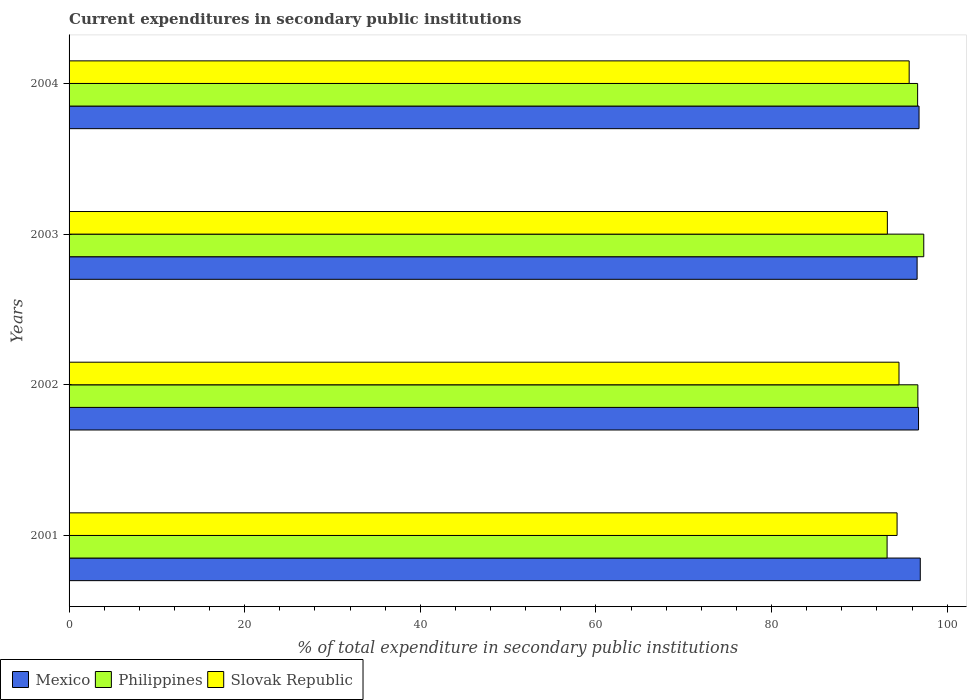How many groups of bars are there?
Give a very brief answer. 4. Are the number of bars per tick equal to the number of legend labels?
Your answer should be compact. Yes. Are the number of bars on each tick of the Y-axis equal?
Your answer should be very brief. Yes. How many bars are there on the 2nd tick from the bottom?
Your answer should be compact. 3. What is the current expenditures in secondary public institutions in Mexico in 2004?
Make the answer very short. 96.8. Across all years, what is the maximum current expenditures in secondary public institutions in Slovak Republic?
Offer a very short reply. 95.68. Across all years, what is the minimum current expenditures in secondary public institutions in Mexico?
Your response must be concise. 96.58. In which year was the current expenditures in secondary public institutions in Slovak Republic maximum?
Provide a succinct answer. 2004. What is the total current expenditures in secondary public institutions in Slovak Republic in the graph?
Provide a succinct answer. 377.7. What is the difference between the current expenditures in secondary public institutions in Slovak Republic in 2002 and that in 2003?
Ensure brevity in your answer.  1.33. What is the difference between the current expenditures in secondary public institutions in Philippines in 2001 and the current expenditures in secondary public institutions in Slovak Republic in 2003?
Make the answer very short. -0.03. What is the average current expenditures in secondary public institutions in Philippines per year?
Give a very brief answer. 95.95. In the year 2001, what is the difference between the current expenditures in secondary public institutions in Philippines and current expenditures in secondary public institutions in Mexico?
Provide a short and direct response. -3.78. In how many years, is the current expenditures in secondary public institutions in Mexico greater than 96 %?
Your answer should be compact. 4. What is the ratio of the current expenditures in secondary public institutions in Mexico in 2001 to that in 2004?
Your answer should be very brief. 1. Is the current expenditures in secondary public institutions in Slovak Republic in 2002 less than that in 2004?
Make the answer very short. Yes. What is the difference between the highest and the second highest current expenditures in secondary public institutions in Philippines?
Your answer should be very brief. 0.67. What is the difference between the highest and the lowest current expenditures in secondary public institutions in Mexico?
Keep it short and to the point. 0.36. Is the sum of the current expenditures in secondary public institutions in Mexico in 2002 and 2004 greater than the maximum current expenditures in secondary public institutions in Slovak Republic across all years?
Keep it short and to the point. Yes. What does the 1st bar from the top in 2002 represents?
Make the answer very short. Slovak Republic. How many bars are there?
Offer a terse response. 12. How many years are there in the graph?
Provide a succinct answer. 4. What is the difference between two consecutive major ticks on the X-axis?
Keep it short and to the point. 20. How many legend labels are there?
Your answer should be compact. 3. What is the title of the graph?
Make the answer very short. Current expenditures in secondary public institutions. What is the label or title of the X-axis?
Your response must be concise. % of total expenditure in secondary public institutions. What is the label or title of the Y-axis?
Keep it short and to the point. Years. What is the % of total expenditure in secondary public institutions of Mexico in 2001?
Your answer should be compact. 96.94. What is the % of total expenditure in secondary public institutions in Philippines in 2001?
Offer a very short reply. 93.16. What is the % of total expenditure in secondary public institutions of Slovak Republic in 2001?
Offer a terse response. 94.3. What is the % of total expenditure in secondary public institutions of Mexico in 2002?
Your response must be concise. 96.74. What is the % of total expenditure in secondary public institutions in Philippines in 2002?
Ensure brevity in your answer.  96.67. What is the % of total expenditure in secondary public institutions in Slovak Republic in 2002?
Offer a very short reply. 94.52. What is the % of total expenditure in secondary public institutions in Mexico in 2003?
Your answer should be very brief. 96.58. What is the % of total expenditure in secondary public institutions of Philippines in 2003?
Offer a terse response. 97.34. What is the % of total expenditure in secondary public institutions in Slovak Republic in 2003?
Give a very brief answer. 93.19. What is the % of total expenditure in secondary public institutions of Mexico in 2004?
Your answer should be very brief. 96.8. What is the % of total expenditure in secondary public institutions of Philippines in 2004?
Offer a very short reply. 96.64. What is the % of total expenditure in secondary public institutions of Slovak Republic in 2004?
Your answer should be compact. 95.68. Across all years, what is the maximum % of total expenditure in secondary public institutions of Mexico?
Make the answer very short. 96.94. Across all years, what is the maximum % of total expenditure in secondary public institutions of Philippines?
Make the answer very short. 97.34. Across all years, what is the maximum % of total expenditure in secondary public institutions in Slovak Republic?
Make the answer very short. 95.68. Across all years, what is the minimum % of total expenditure in secondary public institutions in Mexico?
Your response must be concise. 96.58. Across all years, what is the minimum % of total expenditure in secondary public institutions of Philippines?
Give a very brief answer. 93.16. Across all years, what is the minimum % of total expenditure in secondary public institutions in Slovak Republic?
Ensure brevity in your answer.  93.19. What is the total % of total expenditure in secondary public institutions of Mexico in the graph?
Make the answer very short. 387.07. What is the total % of total expenditure in secondary public institutions of Philippines in the graph?
Give a very brief answer. 383.81. What is the total % of total expenditure in secondary public institutions of Slovak Republic in the graph?
Your response must be concise. 377.7. What is the difference between the % of total expenditure in secondary public institutions in Mexico in 2001 and that in 2002?
Your answer should be very brief. 0.2. What is the difference between the % of total expenditure in secondary public institutions of Philippines in 2001 and that in 2002?
Provide a succinct answer. -3.5. What is the difference between the % of total expenditure in secondary public institutions of Slovak Republic in 2001 and that in 2002?
Provide a short and direct response. -0.22. What is the difference between the % of total expenditure in secondary public institutions of Mexico in 2001 and that in 2003?
Ensure brevity in your answer.  0.36. What is the difference between the % of total expenditure in secondary public institutions in Philippines in 2001 and that in 2003?
Your answer should be compact. -4.18. What is the difference between the % of total expenditure in secondary public institutions of Slovak Republic in 2001 and that in 2003?
Your response must be concise. 1.11. What is the difference between the % of total expenditure in secondary public institutions in Mexico in 2001 and that in 2004?
Offer a very short reply. 0.14. What is the difference between the % of total expenditure in secondary public institutions of Philippines in 2001 and that in 2004?
Provide a short and direct response. -3.48. What is the difference between the % of total expenditure in secondary public institutions of Slovak Republic in 2001 and that in 2004?
Keep it short and to the point. -1.38. What is the difference between the % of total expenditure in secondary public institutions of Mexico in 2002 and that in 2003?
Provide a succinct answer. 0.16. What is the difference between the % of total expenditure in secondary public institutions of Philippines in 2002 and that in 2003?
Make the answer very short. -0.67. What is the difference between the % of total expenditure in secondary public institutions of Slovak Republic in 2002 and that in 2003?
Keep it short and to the point. 1.33. What is the difference between the % of total expenditure in secondary public institutions in Mexico in 2002 and that in 2004?
Provide a succinct answer. -0.06. What is the difference between the % of total expenditure in secondary public institutions of Philippines in 2002 and that in 2004?
Offer a terse response. 0.03. What is the difference between the % of total expenditure in secondary public institutions in Slovak Republic in 2002 and that in 2004?
Offer a very short reply. -1.16. What is the difference between the % of total expenditure in secondary public institutions of Mexico in 2003 and that in 2004?
Provide a succinct answer. -0.22. What is the difference between the % of total expenditure in secondary public institutions of Philippines in 2003 and that in 2004?
Your answer should be compact. 0.7. What is the difference between the % of total expenditure in secondary public institutions in Slovak Republic in 2003 and that in 2004?
Your answer should be compact. -2.48. What is the difference between the % of total expenditure in secondary public institutions of Mexico in 2001 and the % of total expenditure in secondary public institutions of Philippines in 2002?
Offer a very short reply. 0.28. What is the difference between the % of total expenditure in secondary public institutions in Mexico in 2001 and the % of total expenditure in secondary public institutions in Slovak Republic in 2002?
Your response must be concise. 2.42. What is the difference between the % of total expenditure in secondary public institutions in Philippines in 2001 and the % of total expenditure in secondary public institutions in Slovak Republic in 2002?
Your answer should be compact. -1.36. What is the difference between the % of total expenditure in secondary public institutions of Mexico in 2001 and the % of total expenditure in secondary public institutions of Philippines in 2003?
Your answer should be very brief. -0.4. What is the difference between the % of total expenditure in secondary public institutions of Mexico in 2001 and the % of total expenditure in secondary public institutions of Slovak Republic in 2003?
Give a very brief answer. 3.75. What is the difference between the % of total expenditure in secondary public institutions in Philippines in 2001 and the % of total expenditure in secondary public institutions in Slovak Republic in 2003?
Offer a terse response. -0.03. What is the difference between the % of total expenditure in secondary public institutions of Mexico in 2001 and the % of total expenditure in secondary public institutions of Philippines in 2004?
Keep it short and to the point. 0.3. What is the difference between the % of total expenditure in secondary public institutions of Mexico in 2001 and the % of total expenditure in secondary public institutions of Slovak Republic in 2004?
Make the answer very short. 1.26. What is the difference between the % of total expenditure in secondary public institutions in Philippines in 2001 and the % of total expenditure in secondary public institutions in Slovak Republic in 2004?
Ensure brevity in your answer.  -2.52. What is the difference between the % of total expenditure in secondary public institutions in Mexico in 2002 and the % of total expenditure in secondary public institutions in Philippines in 2003?
Provide a short and direct response. -0.6. What is the difference between the % of total expenditure in secondary public institutions of Mexico in 2002 and the % of total expenditure in secondary public institutions of Slovak Republic in 2003?
Offer a very short reply. 3.55. What is the difference between the % of total expenditure in secondary public institutions in Philippines in 2002 and the % of total expenditure in secondary public institutions in Slovak Republic in 2003?
Provide a succinct answer. 3.47. What is the difference between the % of total expenditure in secondary public institutions in Mexico in 2002 and the % of total expenditure in secondary public institutions in Philippines in 2004?
Give a very brief answer. 0.1. What is the difference between the % of total expenditure in secondary public institutions in Mexico in 2002 and the % of total expenditure in secondary public institutions in Slovak Republic in 2004?
Your answer should be compact. 1.07. What is the difference between the % of total expenditure in secondary public institutions of Philippines in 2002 and the % of total expenditure in secondary public institutions of Slovak Republic in 2004?
Provide a short and direct response. 0.99. What is the difference between the % of total expenditure in secondary public institutions of Mexico in 2003 and the % of total expenditure in secondary public institutions of Philippines in 2004?
Ensure brevity in your answer.  -0.06. What is the difference between the % of total expenditure in secondary public institutions in Mexico in 2003 and the % of total expenditure in secondary public institutions in Slovak Republic in 2004?
Make the answer very short. 0.9. What is the difference between the % of total expenditure in secondary public institutions in Philippines in 2003 and the % of total expenditure in secondary public institutions in Slovak Republic in 2004?
Ensure brevity in your answer.  1.66. What is the average % of total expenditure in secondary public institutions in Mexico per year?
Keep it short and to the point. 96.77. What is the average % of total expenditure in secondary public institutions in Philippines per year?
Ensure brevity in your answer.  95.95. What is the average % of total expenditure in secondary public institutions in Slovak Republic per year?
Offer a very short reply. 94.42. In the year 2001, what is the difference between the % of total expenditure in secondary public institutions in Mexico and % of total expenditure in secondary public institutions in Philippines?
Offer a terse response. 3.78. In the year 2001, what is the difference between the % of total expenditure in secondary public institutions in Mexico and % of total expenditure in secondary public institutions in Slovak Republic?
Provide a succinct answer. 2.64. In the year 2001, what is the difference between the % of total expenditure in secondary public institutions of Philippines and % of total expenditure in secondary public institutions of Slovak Republic?
Keep it short and to the point. -1.14. In the year 2002, what is the difference between the % of total expenditure in secondary public institutions in Mexico and % of total expenditure in secondary public institutions in Philippines?
Make the answer very short. 0.08. In the year 2002, what is the difference between the % of total expenditure in secondary public institutions in Mexico and % of total expenditure in secondary public institutions in Slovak Republic?
Ensure brevity in your answer.  2.22. In the year 2002, what is the difference between the % of total expenditure in secondary public institutions in Philippines and % of total expenditure in secondary public institutions in Slovak Republic?
Your answer should be compact. 2.15. In the year 2003, what is the difference between the % of total expenditure in secondary public institutions in Mexico and % of total expenditure in secondary public institutions in Philippines?
Offer a terse response. -0.76. In the year 2003, what is the difference between the % of total expenditure in secondary public institutions in Mexico and % of total expenditure in secondary public institutions in Slovak Republic?
Offer a very short reply. 3.39. In the year 2003, what is the difference between the % of total expenditure in secondary public institutions in Philippines and % of total expenditure in secondary public institutions in Slovak Republic?
Your response must be concise. 4.15. In the year 2004, what is the difference between the % of total expenditure in secondary public institutions of Mexico and % of total expenditure in secondary public institutions of Philippines?
Offer a terse response. 0.16. In the year 2004, what is the difference between the % of total expenditure in secondary public institutions of Mexico and % of total expenditure in secondary public institutions of Slovak Republic?
Make the answer very short. 1.12. In the year 2004, what is the difference between the % of total expenditure in secondary public institutions of Philippines and % of total expenditure in secondary public institutions of Slovak Republic?
Give a very brief answer. 0.96. What is the ratio of the % of total expenditure in secondary public institutions of Mexico in 2001 to that in 2002?
Provide a succinct answer. 1. What is the ratio of the % of total expenditure in secondary public institutions of Philippines in 2001 to that in 2002?
Offer a very short reply. 0.96. What is the ratio of the % of total expenditure in secondary public institutions of Slovak Republic in 2001 to that in 2002?
Offer a very short reply. 1. What is the ratio of the % of total expenditure in secondary public institutions in Mexico in 2001 to that in 2003?
Keep it short and to the point. 1. What is the ratio of the % of total expenditure in secondary public institutions of Philippines in 2001 to that in 2003?
Make the answer very short. 0.96. What is the ratio of the % of total expenditure in secondary public institutions of Slovak Republic in 2001 to that in 2003?
Make the answer very short. 1.01. What is the ratio of the % of total expenditure in secondary public institutions of Slovak Republic in 2001 to that in 2004?
Your answer should be very brief. 0.99. What is the ratio of the % of total expenditure in secondary public institutions in Mexico in 2002 to that in 2003?
Your answer should be compact. 1. What is the ratio of the % of total expenditure in secondary public institutions of Philippines in 2002 to that in 2003?
Offer a very short reply. 0.99. What is the ratio of the % of total expenditure in secondary public institutions in Slovak Republic in 2002 to that in 2003?
Provide a short and direct response. 1.01. What is the ratio of the % of total expenditure in secondary public institutions of Mexico in 2002 to that in 2004?
Provide a succinct answer. 1. What is the ratio of the % of total expenditure in secondary public institutions of Philippines in 2002 to that in 2004?
Offer a very short reply. 1. What is the ratio of the % of total expenditure in secondary public institutions of Slovak Republic in 2002 to that in 2004?
Offer a terse response. 0.99. What is the ratio of the % of total expenditure in secondary public institutions in Mexico in 2003 to that in 2004?
Make the answer very short. 1. What is the ratio of the % of total expenditure in secondary public institutions of Philippines in 2003 to that in 2004?
Make the answer very short. 1.01. What is the difference between the highest and the second highest % of total expenditure in secondary public institutions of Mexico?
Ensure brevity in your answer.  0.14. What is the difference between the highest and the second highest % of total expenditure in secondary public institutions in Philippines?
Your answer should be very brief. 0.67. What is the difference between the highest and the second highest % of total expenditure in secondary public institutions of Slovak Republic?
Give a very brief answer. 1.16. What is the difference between the highest and the lowest % of total expenditure in secondary public institutions in Mexico?
Offer a terse response. 0.36. What is the difference between the highest and the lowest % of total expenditure in secondary public institutions in Philippines?
Make the answer very short. 4.18. What is the difference between the highest and the lowest % of total expenditure in secondary public institutions in Slovak Republic?
Make the answer very short. 2.48. 